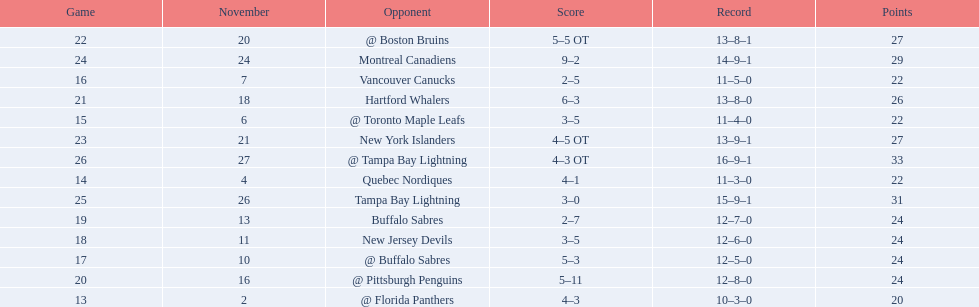Who did the philadelphia flyers play in game 17? @ Buffalo Sabres. What was the score of the november 10th game against the buffalo sabres? 5–3. Which team in the atlantic division had less points than the philadelphia flyers? Tampa Bay Lightning. 